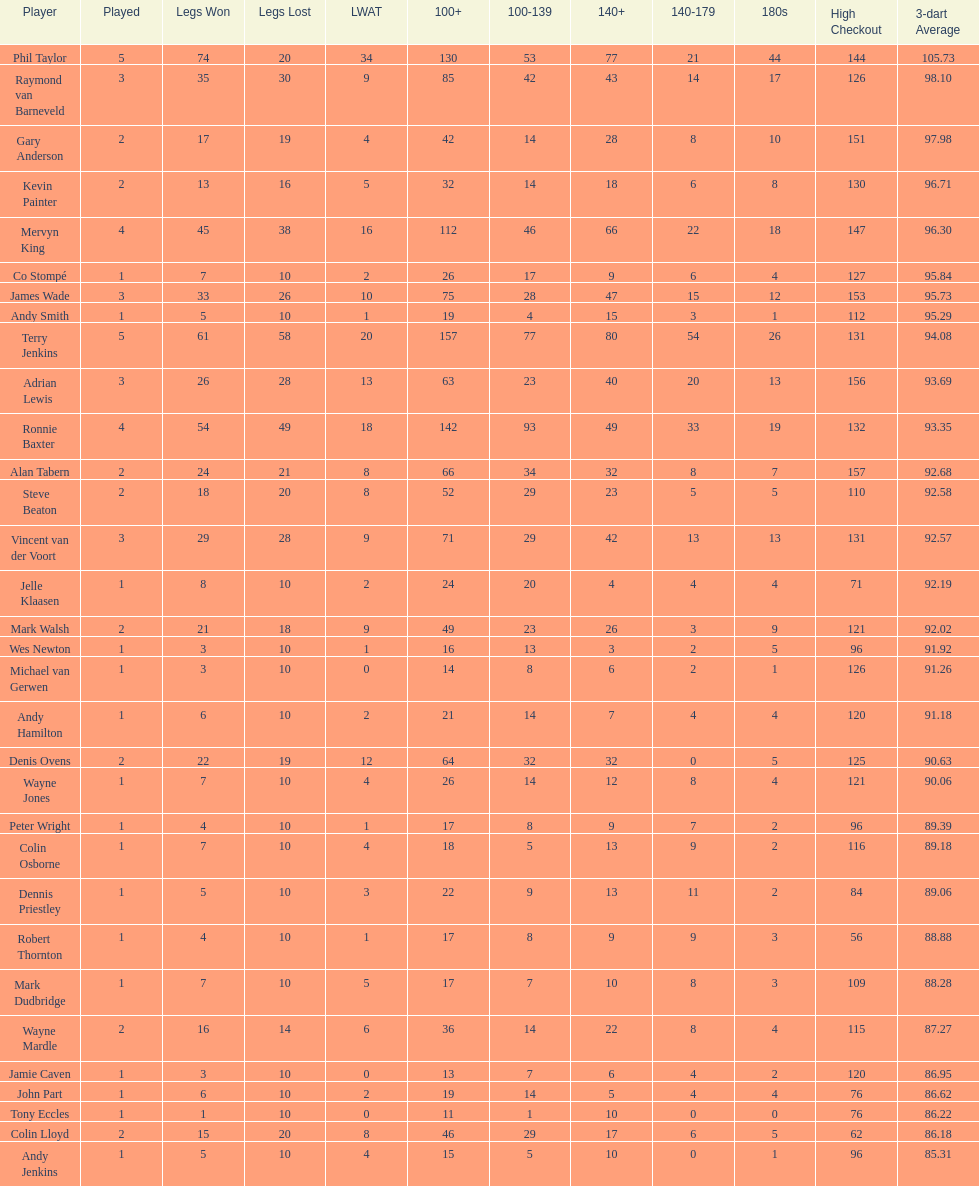What is the total amount of players who played more than 3 games? 4. 